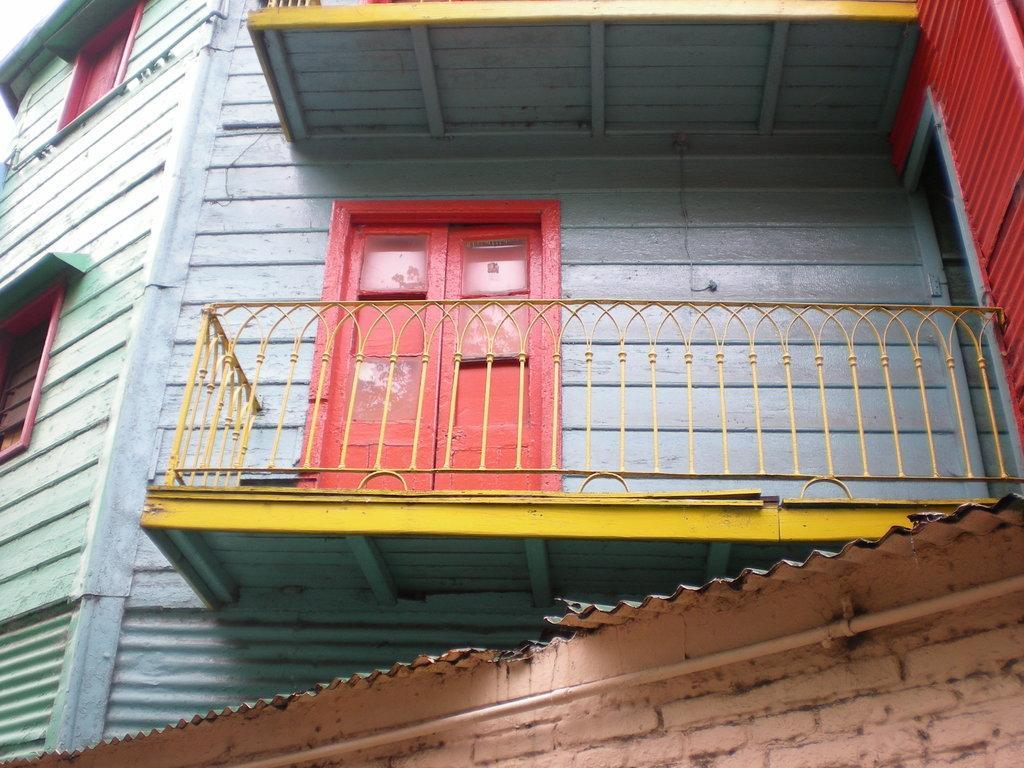Please provide a concise description of this image. This image is taken outdoors. In this image there is a building with walls, windows, a door, balcony and railings. 